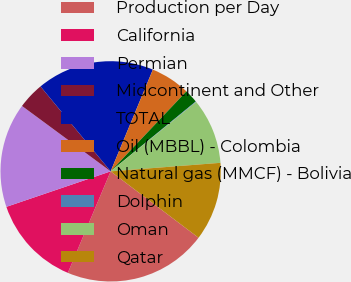Convert chart to OTSL. <chart><loc_0><loc_0><loc_500><loc_500><pie_chart><fcel>Production per Day<fcel>California<fcel>Permian<fcel>Midcontinent and Other<fcel>TOTAL<fcel>Oil (MBBL) - Colombia<fcel>Natural gas (MMCF) - Bolivia<fcel>Dolphin<fcel>Oman<fcel>Qatar<nl><fcel>21.06%<fcel>13.43%<fcel>15.34%<fcel>3.9%<fcel>17.25%<fcel>5.81%<fcel>1.99%<fcel>0.09%<fcel>9.62%<fcel>11.53%<nl></chart> 